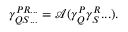Convert formula to latex. <formula><loc_0><loc_0><loc_500><loc_500>\begin{array} { r } { \gamma _ { Q S \dots } ^ { P R \dots } = \mathcal { A } ( \gamma _ { Q } ^ { P } \gamma _ { S } ^ { R } \dots ) . } \end{array}</formula> 